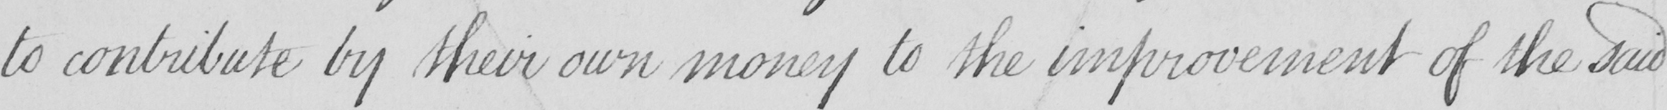What is written in this line of handwriting? to contribute by their own money to the improvement of the said 